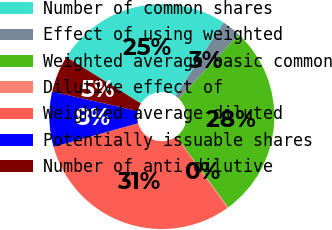Convert chart to OTSL. <chart><loc_0><loc_0><loc_500><loc_500><pie_chart><fcel>Number of common shares<fcel>Effect of using weighted<fcel>Weighted average basic common<fcel>Dilutive effect of<fcel>Weighted average diluted<fcel>Potentially issuable shares<fcel>Number of anti-dilutive<nl><fcel>25.37%<fcel>2.75%<fcel>27.95%<fcel>0.17%<fcel>30.53%<fcel>7.9%<fcel>5.32%<nl></chart> 